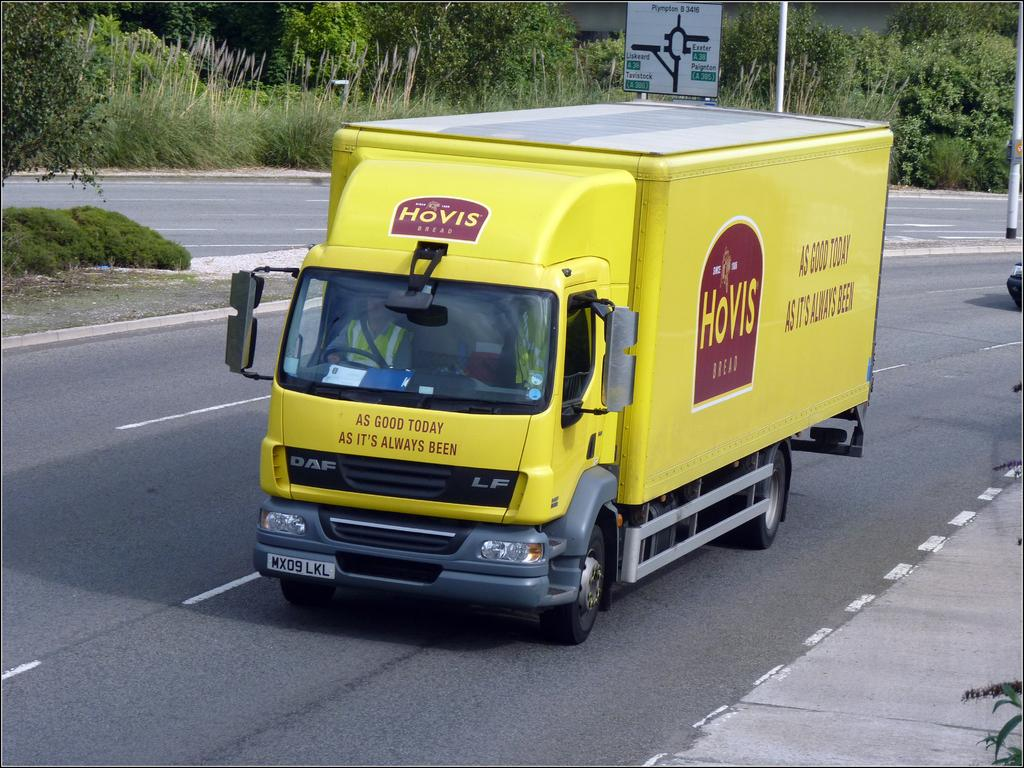What is happening on the road in the image? There are two vehicles moving on the road. What is located in the middle of the road? There is a sign board and a pole in the middle of the road, as well as some grass. What can be seen in the background of the image? There are trees and plants in the background of the image. What type of cracker is being used to plough the field in the image? There is no field or cracker present in the image; it features a road with vehicles, a sign board, a pole, and some grass in the middle. What class is being taught in the image? There is no class or teaching activity depicted in the image. 